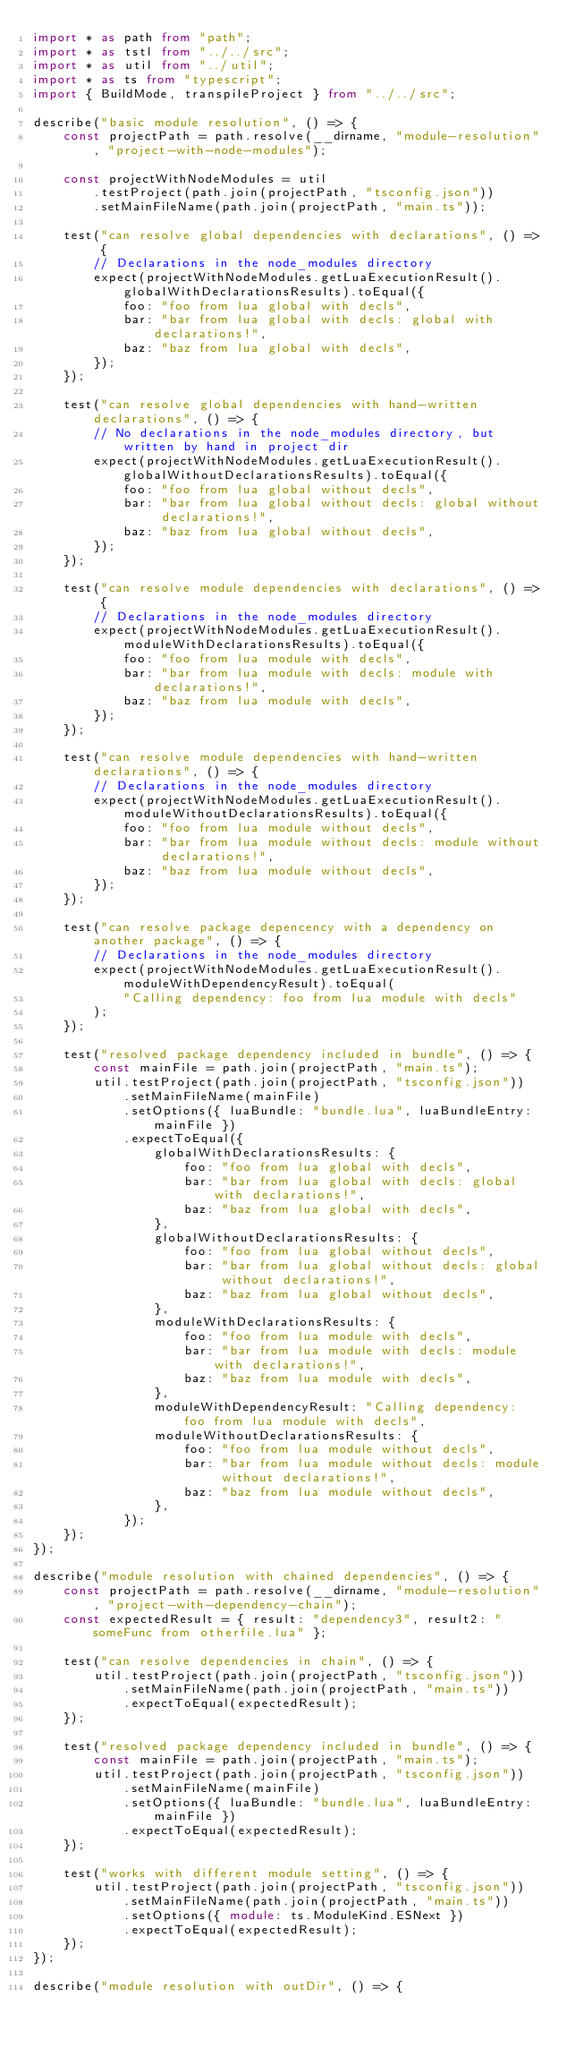Convert code to text. <code><loc_0><loc_0><loc_500><loc_500><_TypeScript_>import * as path from "path";
import * as tstl from "../../src";
import * as util from "../util";
import * as ts from "typescript";
import { BuildMode, transpileProject } from "../../src";

describe("basic module resolution", () => {
    const projectPath = path.resolve(__dirname, "module-resolution", "project-with-node-modules");

    const projectWithNodeModules = util
        .testProject(path.join(projectPath, "tsconfig.json"))
        .setMainFileName(path.join(projectPath, "main.ts"));

    test("can resolve global dependencies with declarations", () => {
        // Declarations in the node_modules directory
        expect(projectWithNodeModules.getLuaExecutionResult().globalWithDeclarationsResults).toEqual({
            foo: "foo from lua global with decls",
            bar: "bar from lua global with decls: global with declarations!",
            baz: "baz from lua global with decls",
        });
    });

    test("can resolve global dependencies with hand-written declarations", () => {
        // No declarations in the node_modules directory, but written by hand in project dir
        expect(projectWithNodeModules.getLuaExecutionResult().globalWithoutDeclarationsResults).toEqual({
            foo: "foo from lua global without decls",
            bar: "bar from lua global without decls: global without declarations!",
            baz: "baz from lua global without decls",
        });
    });

    test("can resolve module dependencies with declarations", () => {
        // Declarations in the node_modules directory
        expect(projectWithNodeModules.getLuaExecutionResult().moduleWithDeclarationsResults).toEqual({
            foo: "foo from lua module with decls",
            bar: "bar from lua module with decls: module with declarations!",
            baz: "baz from lua module with decls",
        });
    });

    test("can resolve module dependencies with hand-written declarations", () => {
        // Declarations in the node_modules directory
        expect(projectWithNodeModules.getLuaExecutionResult().moduleWithoutDeclarationsResults).toEqual({
            foo: "foo from lua module without decls",
            bar: "bar from lua module without decls: module without declarations!",
            baz: "baz from lua module without decls",
        });
    });

    test("can resolve package depencency with a dependency on another package", () => {
        // Declarations in the node_modules directory
        expect(projectWithNodeModules.getLuaExecutionResult().moduleWithDependencyResult).toEqual(
            "Calling dependency: foo from lua module with decls"
        );
    });

    test("resolved package dependency included in bundle", () => {
        const mainFile = path.join(projectPath, "main.ts");
        util.testProject(path.join(projectPath, "tsconfig.json"))
            .setMainFileName(mainFile)
            .setOptions({ luaBundle: "bundle.lua", luaBundleEntry: mainFile })
            .expectToEqual({
                globalWithDeclarationsResults: {
                    foo: "foo from lua global with decls",
                    bar: "bar from lua global with decls: global with declarations!",
                    baz: "baz from lua global with decls",
                },
                globalWithoutDeclarationsResults: {
                    foo: "foo from lua global without decls",
                    bar: "bar from lua global without decls: global without declarations!",
                    baz: "baz from lua global without decls",
                },
                moduleWithDeclarationsResults: {
                    foo: "foo from lua module with decls",
                    bar: "bar from lua module with decls: module with declarations!",
                    baz: "baz from lua module with decls",
                },
                moduleWithDependencyResult: "Calling dependency: foo from lua module with decls",
                moduleWithoutDeclarationsResults: {
                    foo: "foo from lua module without decls",
                    bar: "bar from lua module without decls: module without declarations!",
                    baz: "baz from lua module without decls",
                },
            });
    });
});

describe("module resolution with chained dependencies", () => {
    const projectPath = path.resolve(__dirname, "module-resolution", "project-with-dependency-chain");
    const expectedResult = { result: "dependency3", result2: "someFunc from otherfile.lua" };

    test("can resolve dependencies in chain", () => {
        util.testProject(path.join(projectPath, "tsconfig.json"))
            .setMainFileName(path.join(projectPath, "main.ts"))
            .expectToEqual(expectedResult);
    });

    test("resolved package dependency included in bundle", () => {
        const mainFile = path.join(projectPath, "main.ts");
        util.testProject(path.join(projectPath, "tsconfig.json"))
            .setMainFileName(mainFile)
            .setOptions({ luaBundle: "bundle.lua", luaBundleEntry: mainFile })
            .expectToEqual(expectedResult);
    });

    test("works with different module setting", () => {
        util.testProject(path.join(projectPath, "tsconfig.json"))
            .setMainFileName(path.join(projectPath, "main.ts"))
            .setOptions({ module: ts.ModuleKind.ESNext })
            .expectToEqual(expectedResult);
    });
});

describe("module resolution with outDir", () => {</code> 